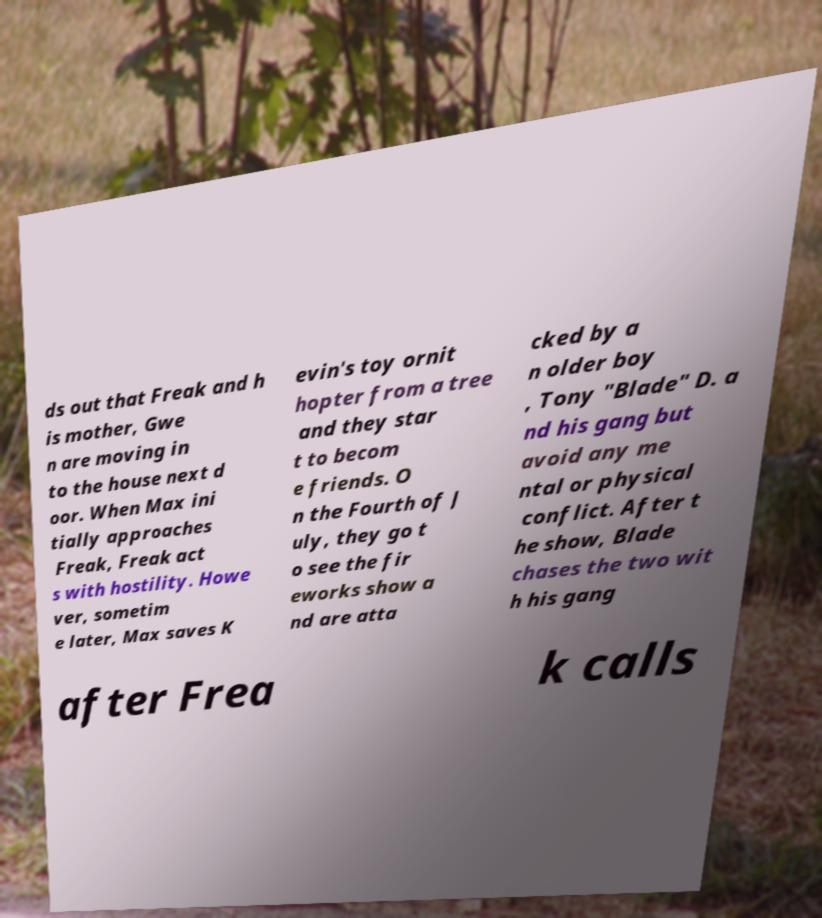Could you extract and type out the text from this image? ds out that Freak and h is mother, Gwe n are moving in to the house next d oor. When Max ini tially approaches Freak, Freak act s with hostility. Howe ver, sometim e later, Max saves K evin's toy ornit hopter from a tree and they star t to becom e friends. O n the Fourth of J uly, they go t o see the fir eworks show a nd are atta cked by a n older boy , Tony "Blade" D. a nd his gang but avoid any me ntal or physical conflict. After t he show, Blade chases the two wit h his gang after Frea k calls 